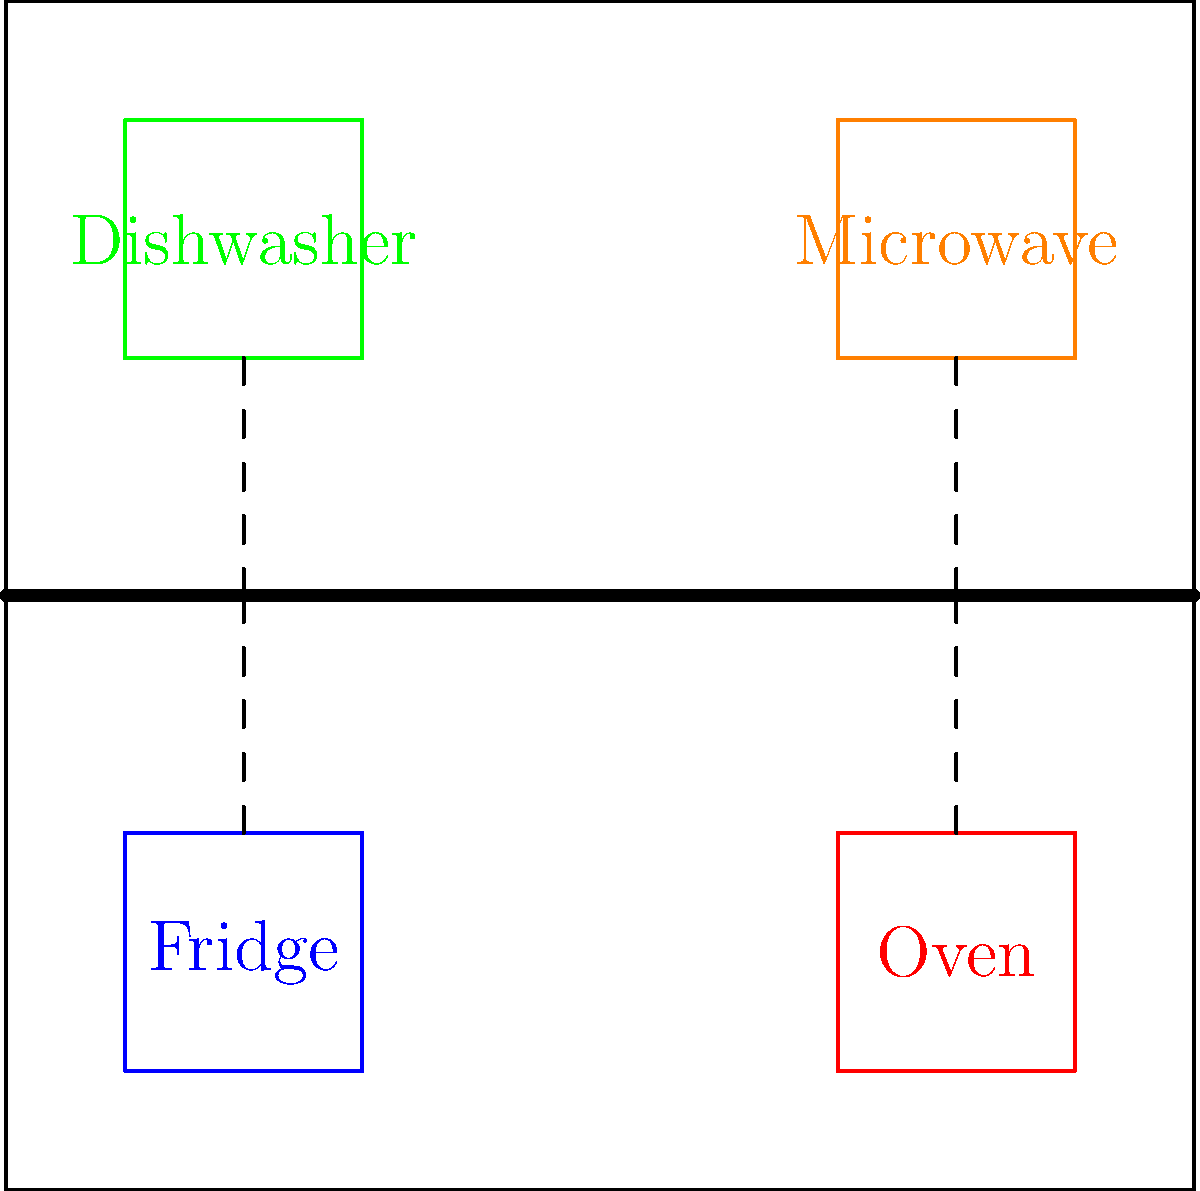In the kitchen wiring diagram shown, which wiring configuration would be most energy-efficient for connecting the appliances to the main power line, considering voltage drop and power loss reduction? To determine the most energy-efficient wiring configuration, we need to consider the following factors:

1. Voltage drop: The voltage drop in a wire is proportional to its length and the current flowing through it. Shorter wires will have less voltage drop.

2. Power loss: Power loss in a wire is proportional to the square of the current and the resistance of the wire. Reducing wire length and using thicker wires can minimize power loss.

3. Load balancing: Distributing the load evenly across the circuit can help reduce overall power loss and improve efficiency.

Analyzing the diagram:

a) The original wiring (dashed lines) connects each appliance directly to the main power line.
b) The proposed energy-efficient wiring (thick gray lines) uses a central distribution point.

The energy-efficient wiring configuration is superior because:

1. It reduces the total wire length, minimizing voltage drop and power loss.
2. It allows for easier load balancing by centralizing the distribution point.
3. It simplifies future modifications or additions to the kitchen's electrical system.
4. The central distribution point can incorporate a power factor correction device or smart energy management system, further improving efficiency.

This configuration aligns with the restaurant owner's commitment to environmental practices by reducing energy waste in the kitchen's electrical system.
Answer: Central distribution wiring (thick gray lines) 